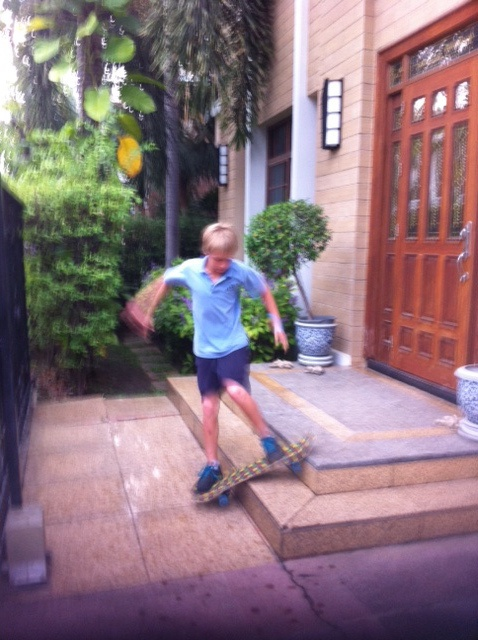Describe the objects in this image and their specific colors. I can see people in white, lightblue, lightpink, and navy tones, potted plant in white, gray, green, and darkgray tones, skateboard in white, darkgray, gray, and purple tones, and potted plant in white, lavender, and violet tones in this image. 